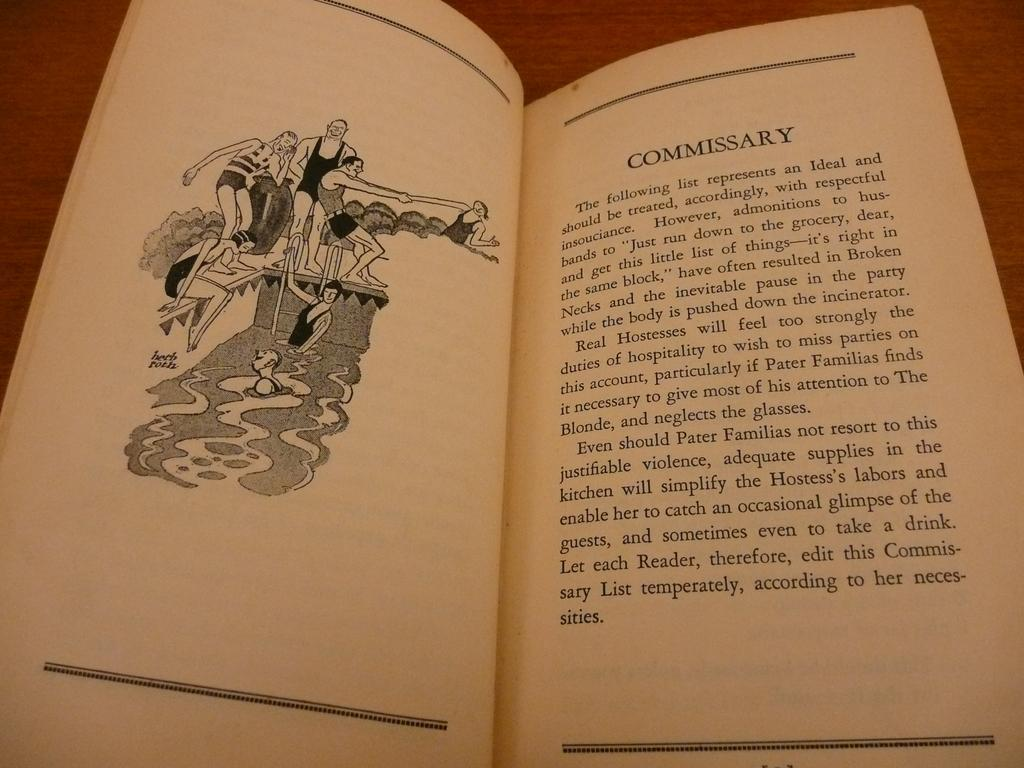<image>
Provide a brief description of the given image. Open book on the page titled COmmissary showing a picture of people diving. 